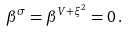Convert formula to latex. <formula><loc_0><loc_0><loc_500><loc_500>\beta ^ { \sigma } = \beta ^ { V + \xi ^ { 2 } } = 0 \, .</formula> 